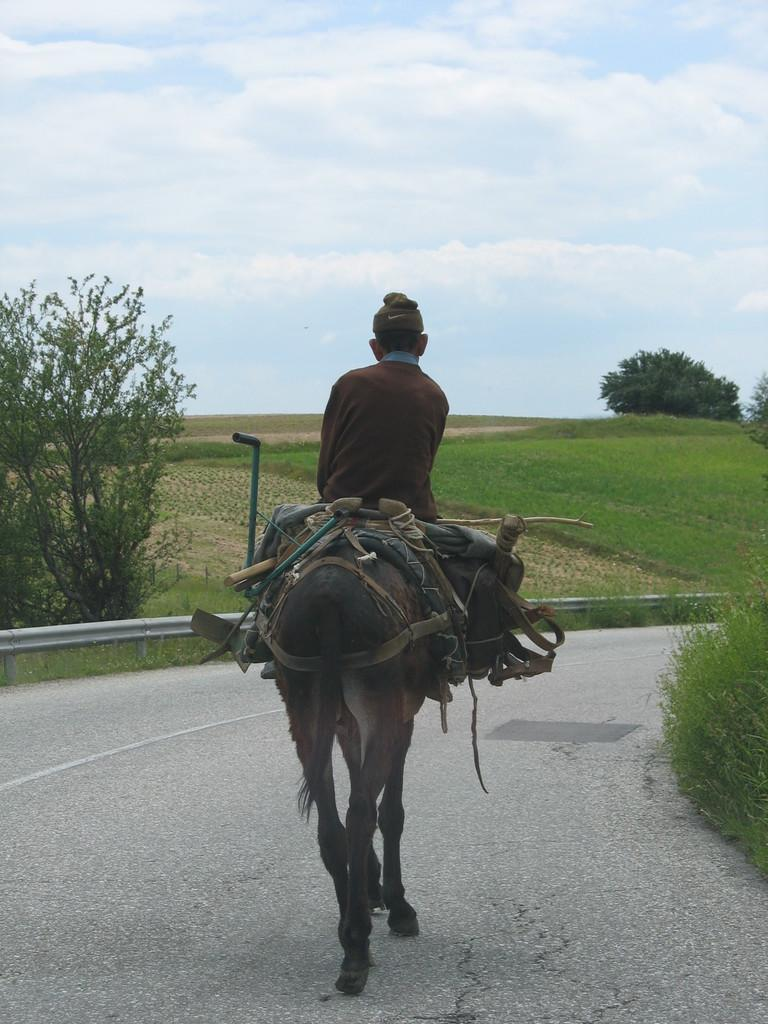Who is present in the image? There is a man in the image. What is the man doing in the image? The man is sitting on an animal. Where are the man and the animal located? They are on a path. What can be seen in the background of the image? There are trees, grass, and the sky visible in the background. What type of blood is visible on the man's clothes in the image? There is no blood visible on the man's clothes in the image. What act is the man performing with the animal in the image? The image only shows the man sitting on the animal, so it is not possible to determine any specific act being performed. 